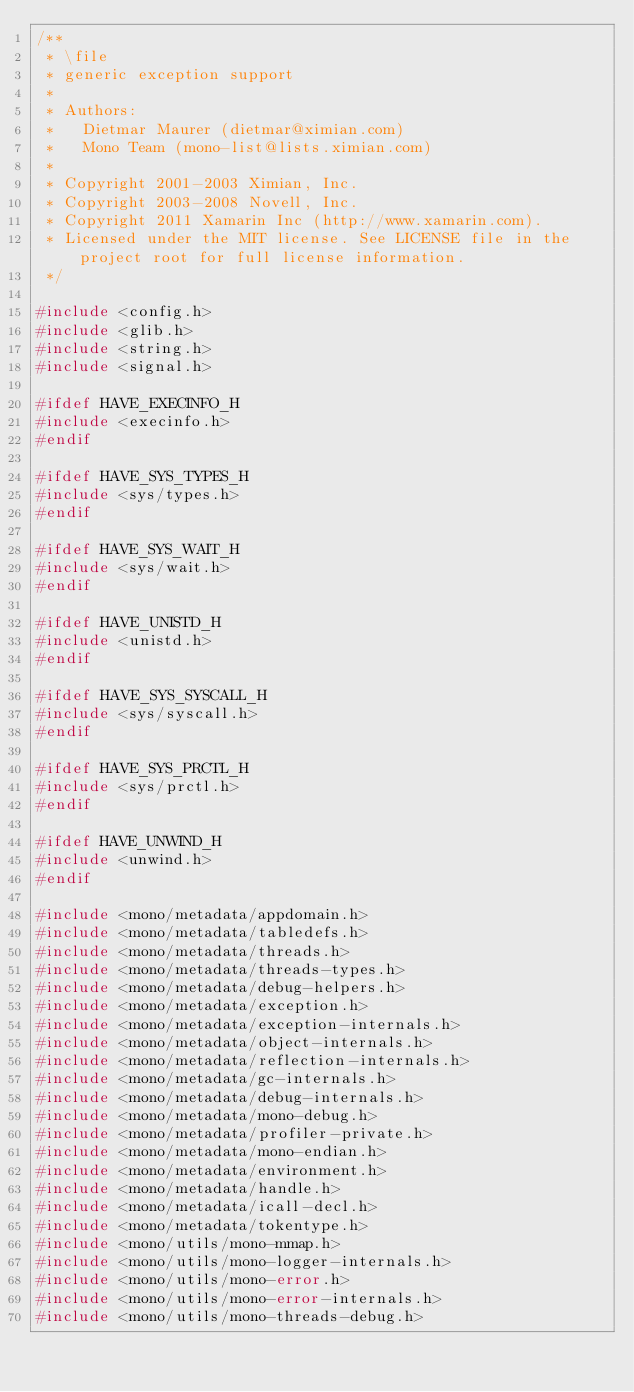Convert code to text. <code><loc_0><loc_0><loc_500><loc_500><_C_>/**
 * \file
 * generic exception support
 *
 * Authors:
 *   Dietmar Maurer (dietmar@ximian.com)
 *   Mono Team (mono-list@lists.ximian.com)
 *
 * Copyright 2001-2003 Ximian, Inc.
 * Copyright 2003-2008 Novell, Inc.
 * Copyright 2011 Xamarin Inc (http://www.xamarin.com).
 * Licensed under the MIT license. See LICENSE file in the project root for full license information.
 */

#include <config.h>
#include <glib.h>
#include <string.h>
#include <signal.h>

#ifdef HAVE_EXECINFO_H
#include <execinfo.h>
#endif

#ifdef HAVE_SYS_TYPES_H
#include <sys/types.h>
#endif

#ifdef HAVE_SYS_WAIT_H
#include <sys/wait.h>
#endif

#ifdef HAVE_UNISTD_H
#include <unistd.h>
#endif

#ifdef HAVE_SYS_SYSCALL_H
#include <sys/syscall.h>
#endif

#ifdef HAVE_SYS_PRCTL_H
#include <sys/prctl.h>
#endif

#ifdef HAVE_UNWIND_H
#include <unwind.h>
#endif

#include <mono/metadata/appdomain.h>
#include <mono/metadata/tabledefs.h>
#include <mono/metadata/threads.h>
#include <mono/metadata/threads-types.h>
#include <mono/metadata/debug-helpers.h>
#include <mono/metadata/exception.h>
#include <mono/metadata/exception-internals.h>
#include <mono/metadata/object-internals.h>
#include <mono/metadata/reflection-internals.h>
#include <mono/metadata/gc-internals.h>
#include <mono/metadata/debug-internals.h>
#include <mono/metadata/mono-debug.h>
#include <mono/metadata/profiler-private.h>
#include <mono/metadata/mono-endian.h>
#include <mono/metadata/environment.h>
#include <mono/metadata/handle.h>
#include <mono/metadata/icall-decl.h>
#include <mono/metadata/tokentype.h>
#include <mono/utils/mono-mmap.h>
#include <mono/utils/mono-logger-internals.h>
#include <mono/utils/mono-error.h>
#include <mono/utils/mono-error-internals.h>
#include <mono/utils/mono-threads-debug.h></code> 